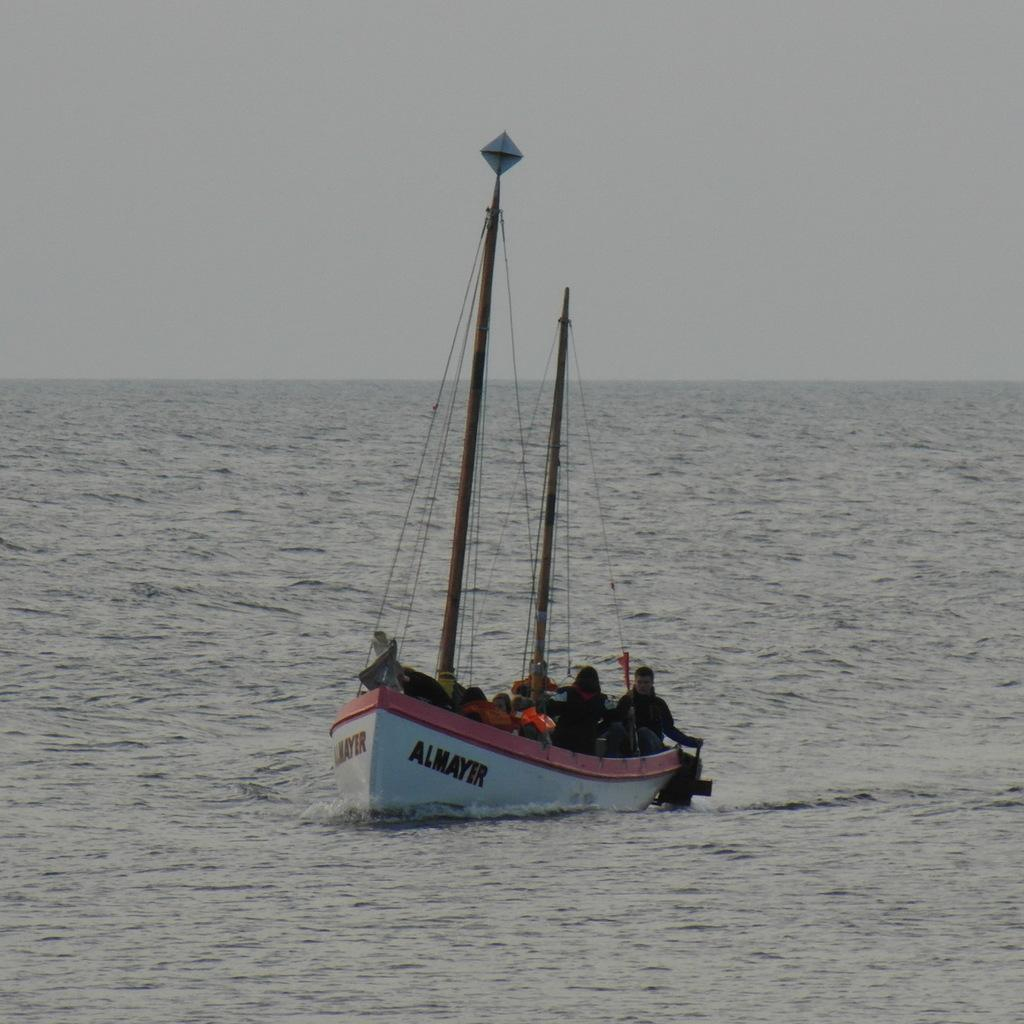What type of boat is in the image? There is a white color boat in the image. Where is the boat located? The boat is on the surface of an ocean. How many people are in the boat? There are two persons in the boat. What can be seen above the boat in the image? The sky is visible at the top of the image. What type of alarm can be heard going off in the boat? There is no alarm present in the image, and therefore no such sound can be heard. 